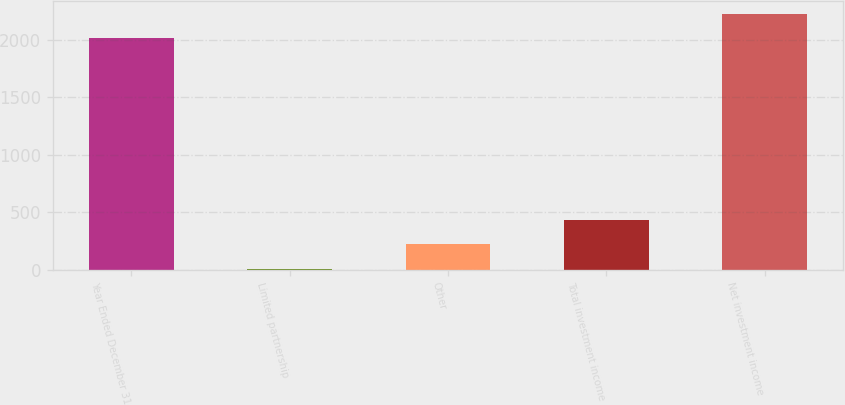<chart> <loc_0><loc_0><loc_500><loc_500><bar_chart><fcel>Year Ended December 31<fcel>Limited partnership<fcel>Other<fcel>Total investment income<fcel>Net investment income<nl><fcel>2016<fcel>9<fcel>221.6<fcel>434.2<fcel>2228.6<nl></chart> 